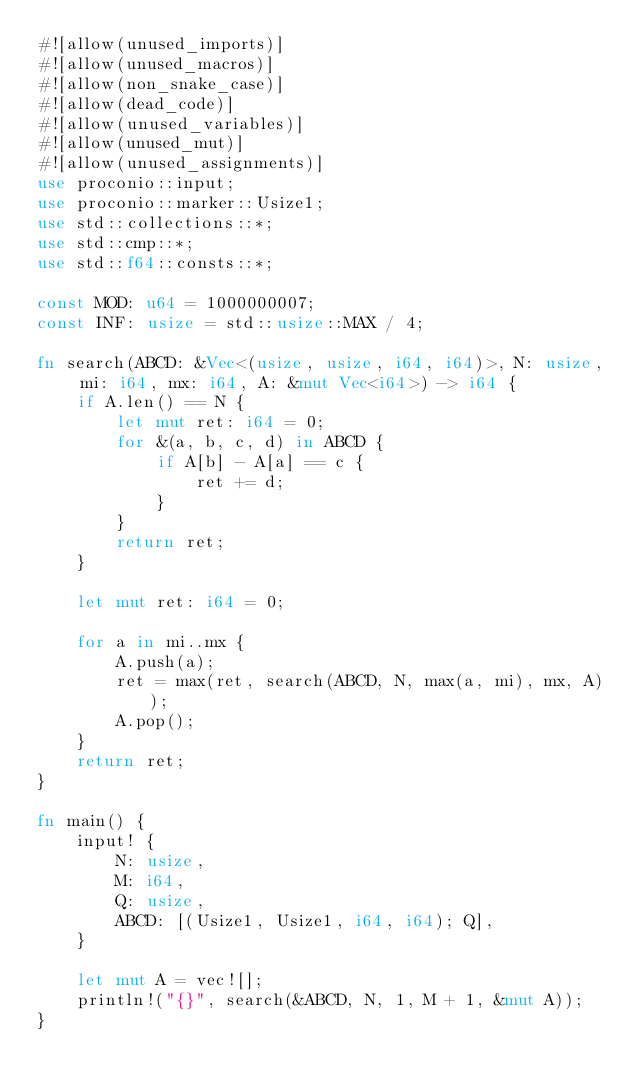<code> <loc_0><loc_0><loc_500><loc_500><_Rust_>#![allow(unused_imports)]
#![allow(unused_macros)]
#![allow(non_snake_case)]
#![allow(dead_code)]
#![allow(unused_variables)]
#![allow(unused_mut)]
#![allow(unused_assignments)]
use proconio::input;
use proconio::marker::Usize1;
use std::collections::*;
use std::cmp::*;
use std::f64::consts::*;

const MOD: u64 = 1000000007;
const INF: usize = std::usize::MAX / 4;

fn search(ABCD: &Vec<(usize, usize, i64, i64)>, N: usize, mi: i64, mx: i64, A: &mut Vec<i64>) -> i64 {
    if A.len() == N {
        let mut ret: i64 = 0;
        for &(a, b, c, d) in ABCD {
            if A[b] - A[a] == c {
                ret += d;
            }
        }
        return ret;
    }

    let mut ret: i64 = 0;

    for a in mi..mx {
        A.push(a);
        ret = max(ret, search(ABCD, N, max(a, mi), mx, A));
        A.pop();
    }
    return ret;
}

fn main() {
    input! {
        N: usize,
        M: i64,
        Q: usize,
        ABCD: [(Usize1, Usize1, i64, i64); Q],
    }

    let mut A = vec![];
    println!("{}", search(&ABCD, N, 1, M + 1, &mut A));
}
</code> 